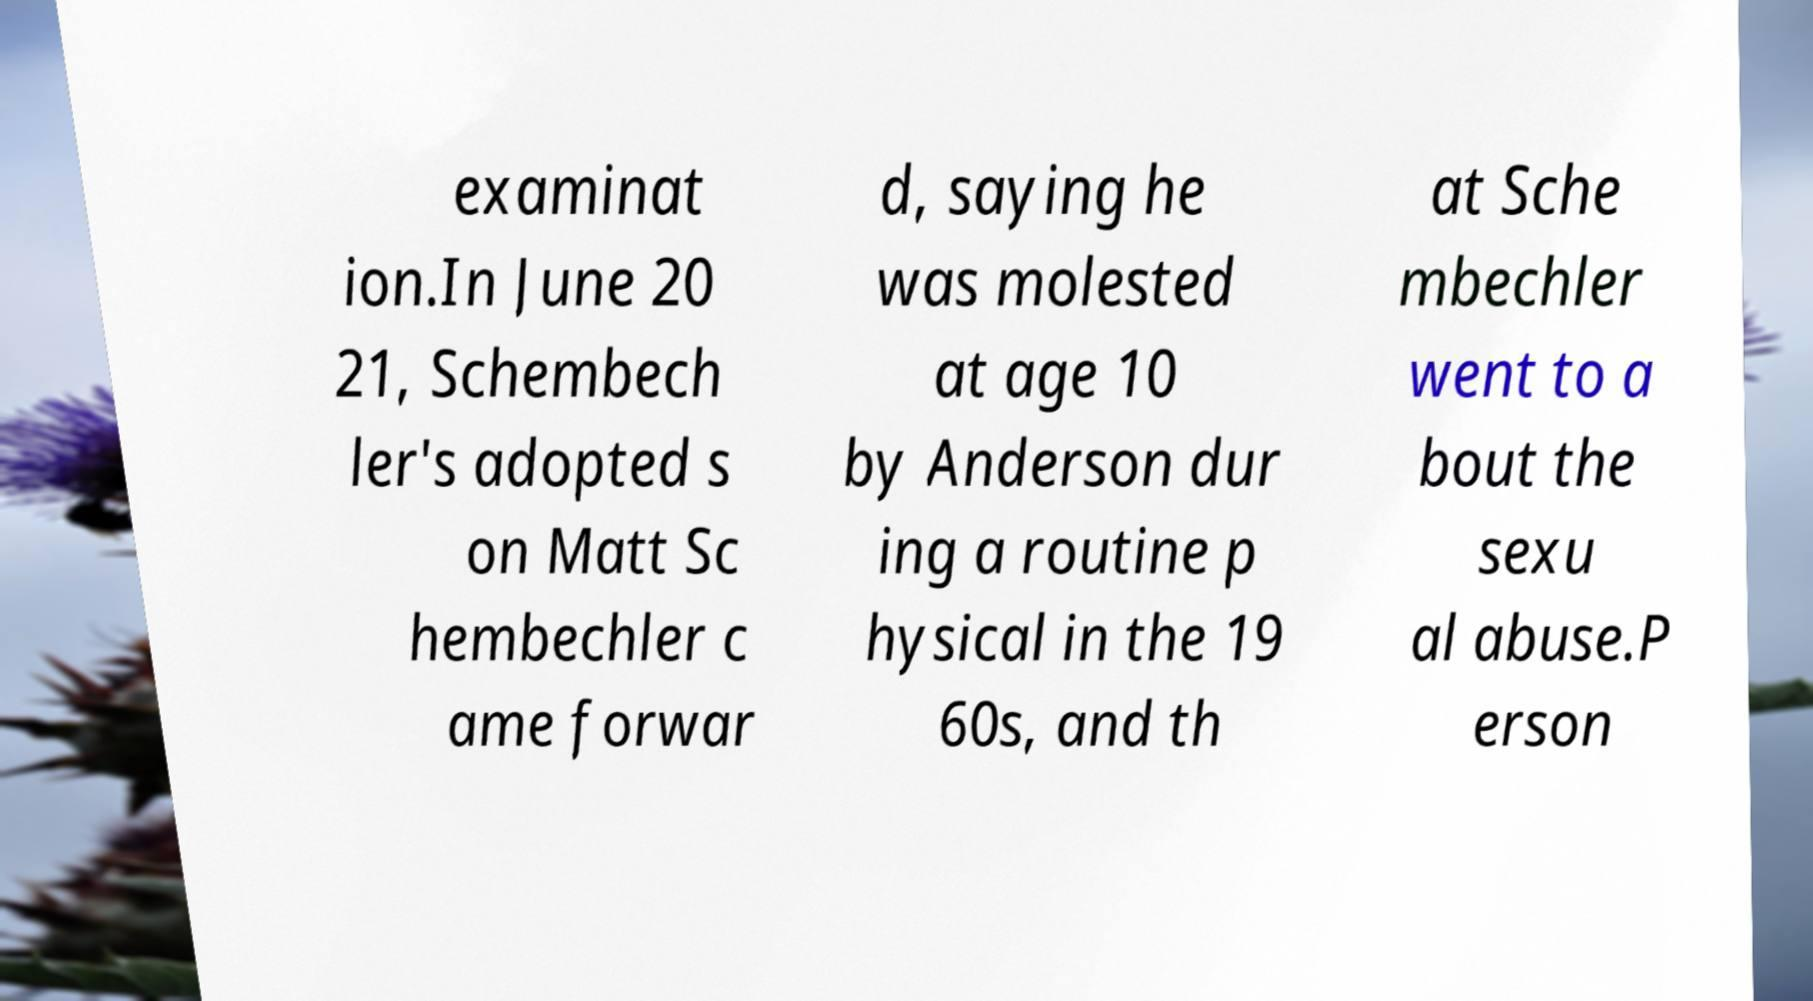Could you extract and type out the text from this image? examinat ion.In June 20 21, Schembech ler's adopted s on Matt Sc hembechler c ame forwar d, saying he was molested at age 10 by Anderson dur ing a routine p hysical in the 19 60s, and th at Sche mbechler went to a bout the sexu al abuse.P erson 